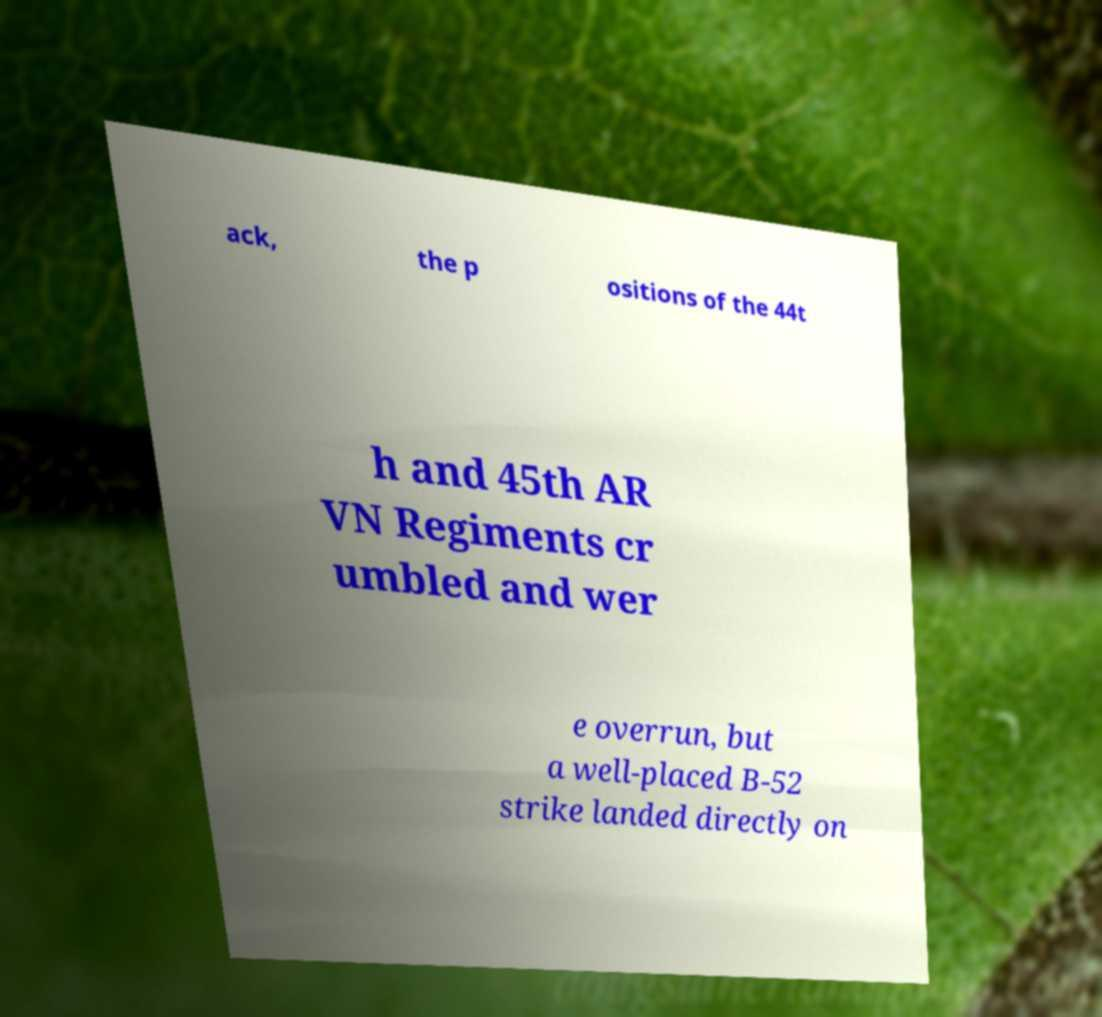For documentation purposes, I need the text within this image transcribed. Could you provide that? ack, the p ositions of the 44t h and 45th AR VN Regiments cr umbled and wer e overrun, but a well-placed B-52 strike landed directly on 